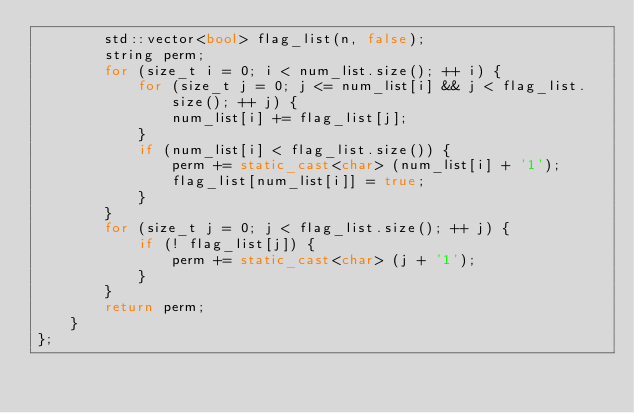<code> <loc_0><loc_0><loc_500><loc_500><_C++_>		std::vector<bool> flag_list(n, false);
		string perm;
		for (size_t i = 0; i < num_list.size(); ++ i) {
			for (size_t j = 0; j <= num_list[i] && j < flag_list.size(); ++ j) {
				num_list[i] += flag_list[j];
			}
			if (num_list[i] < flag_list.size()) {
				perm += static_cast<char> (num_list[i] + '1');
				flag_list[num_list[i]] = true;
			}
		}
		for (size_t j = 0; j < flag_list.size(); ++ j) {
			if (! flag_list[j]) {
				perm += static_cast<char> (j + '1');
			}
		}
		return perm;
    }
};
</code> 